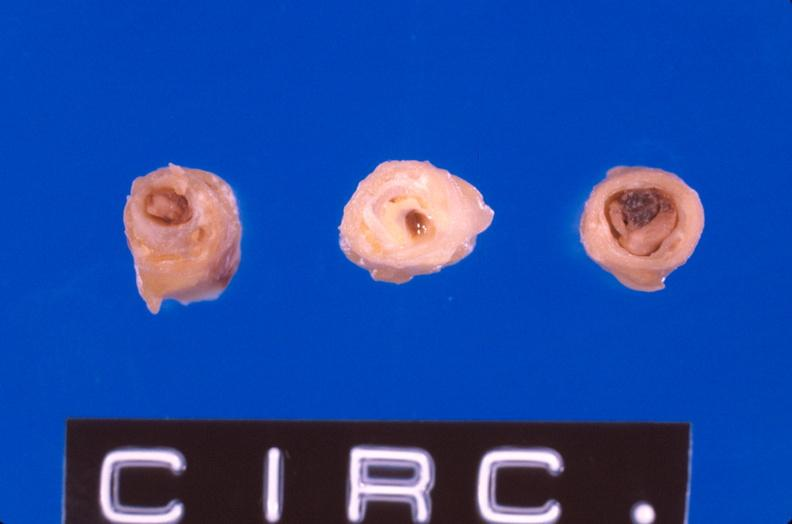does this image show coronary artery atherosclerosis?
Answer the question using a single word or phrase. Yes 